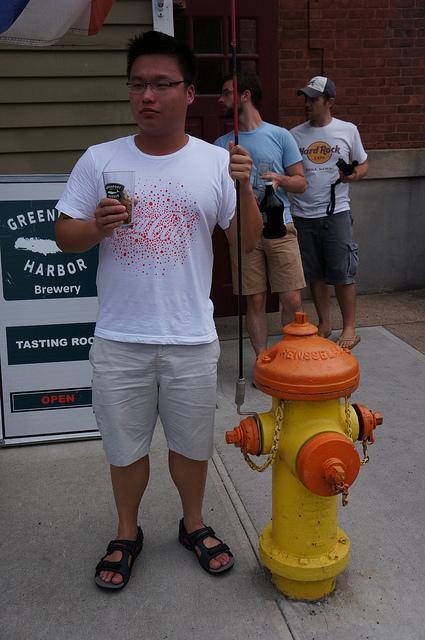How many people are visible?
Give a very brief answer. 3. 